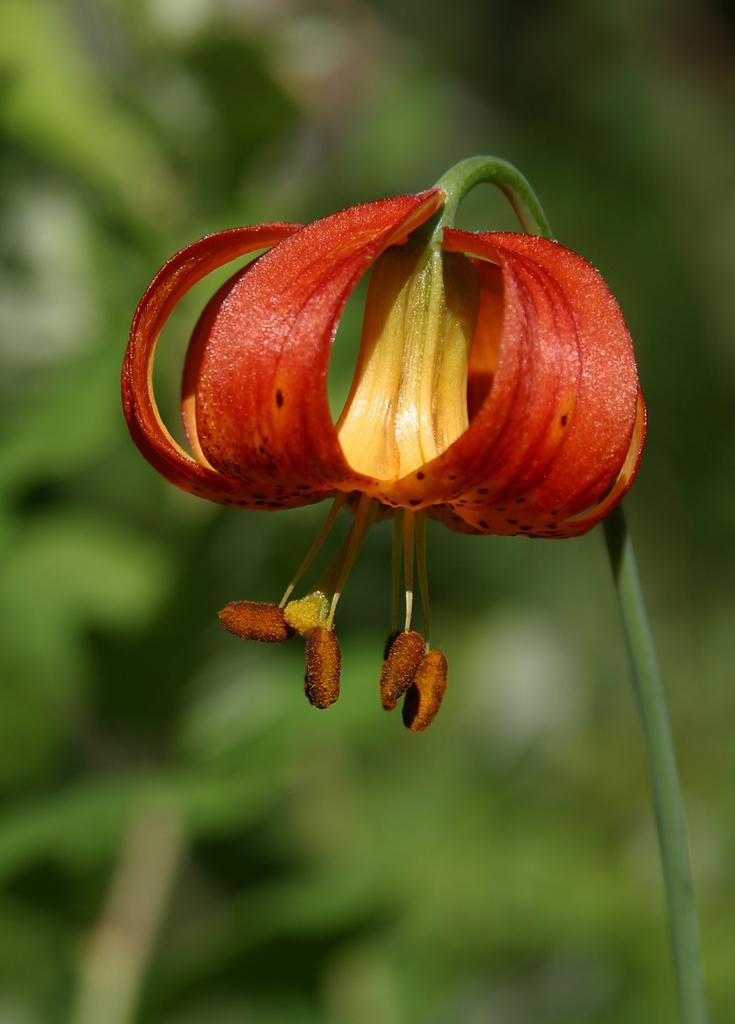Describe this image in one or two sentences. In this image, we can see a flower which is in orange color. 